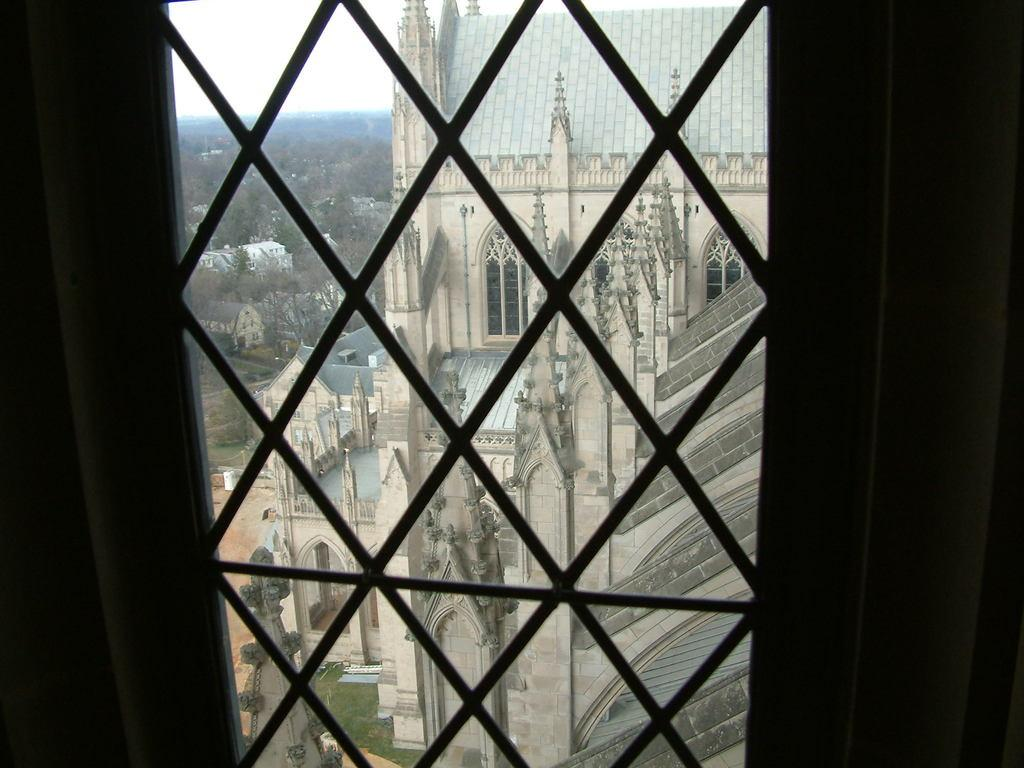What is located in the center of the image? There is a window in the center of the image. What can be seen through the window? Buildings, trees, grass, and a walkway are visible through the window. Can you see a ghost walking through the buildings in the image? There is no ghost present in the image, and therefore no such activity can be observed. 